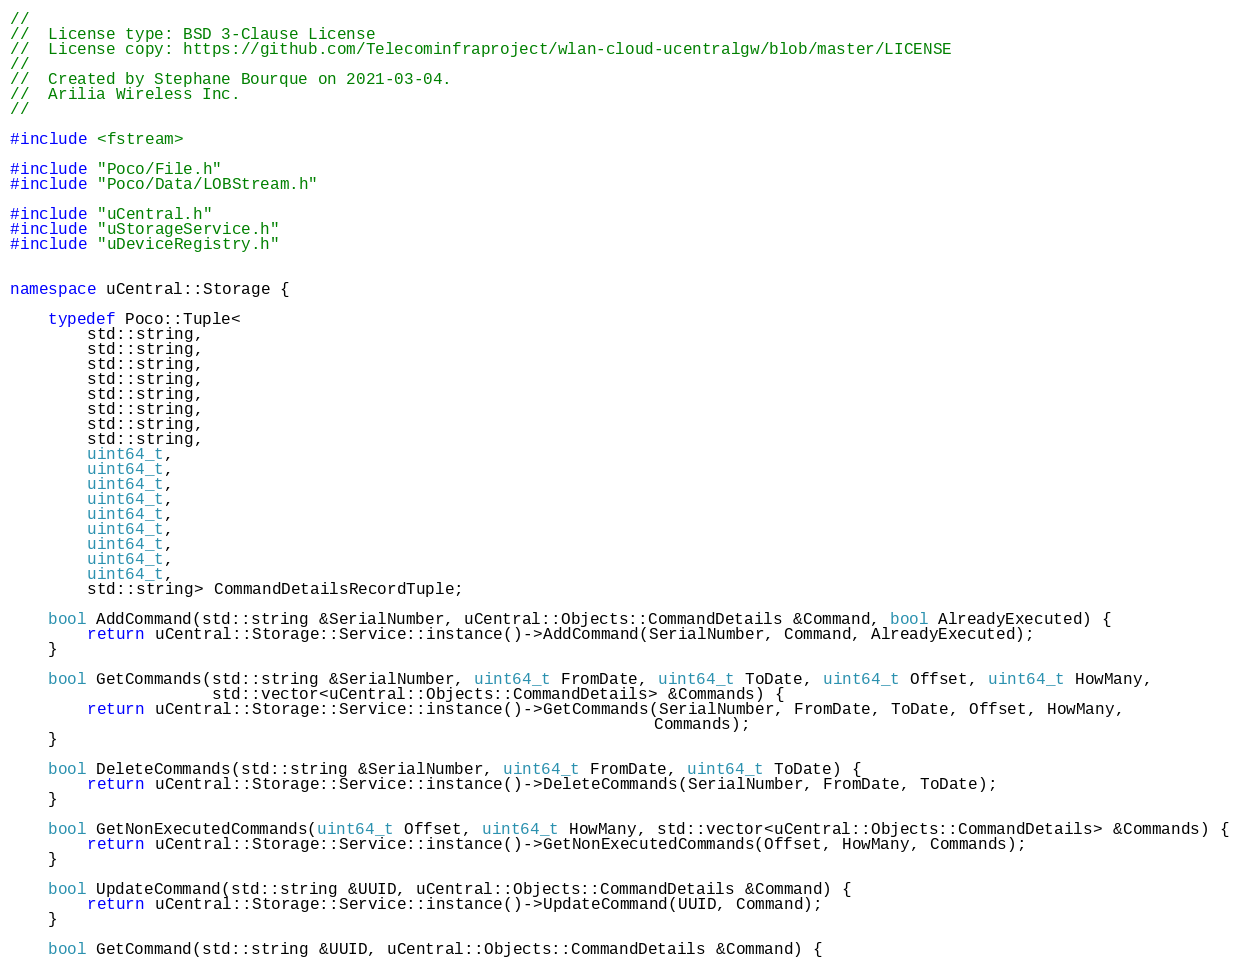Convert code to text. <code><loc_0><loc_0><loc_500><loc_500><_C++_>//
//	License type: BSD 3-Clause License
//	License copy: https://github.com/Telecominfraproject/wlan-cloud-ucentralgw/blob/master/LICENSE
//
//	Created by Stephane Bourque on 2021-03-04.
//	Arilia Wireless Inc.
//

#include <fstream>

#include "Poco/File.h"
#include "Poco/Data/LOBStream.h"

#include "uCentral.h"
#include "uStorageService.h"
#include "uDeviceRegistry.h"


namespace uCentral::Storage {

	typedef Poco::Tuple<
		std::string,
		std::string,
		std::string,
		std::string,
		std::string,
		std::string,
		std::string,
		std::string,
		uint64_t,
		uint64_t,
		uint64_t,
		uint64_t,
		uint64_t,
		uint64_t,
		uint64_t,
		uint64_t,
		uint64_t,
		std::string> CommandDetailsRecordTuple;

	bool AddCommand(std::string &SerialNumber, uCentral::Objects::CommandDetails &Command, bool AlreadyExecuted) {
		return uCentral::Storage::Service::instance()->AddCommand(SerialNumber, Command, AlreadyExecuted);
	}

	bool GetCommands(std::string &SerialNumber, uint64_t FromDate, uint64_t ToDate, uint64_t Offset, uint64_t HowMany,
					 std::vector<uCentral::Objects::CommandDetails> &Commands) {
		return uCentral::Storage::Service::instance()->GetCommands(SerialNumber, FromDate, ToDate, Offset, HowMany,
																   Commands);
	}

	bool DeleteCommands(std::string &SerialNumber, uint64_t FromDate, uint64_t ToDate) {
		return uCentral::Storage::Service::instance()->DeleteCommands(SerialNumber, FromDate, ToDate);
	}

	bool GetNonExecutedCommands(uint64_t Offset, uint64_t HowMany, std::vector<uCentral::Objects::CommandDetails> &Commands) {
		return uCentral::Storage::Service::instance()->GetNonExecutedCommands(Offset, HowMany, Commands);
	}

	bool UpdateCommand(std::string &UUID, uCentral::Objects::CommandDetails &Command) {
		return uCentral::Storage::Service::instance()->UpdateCommand(UUID, Command);
	}

	bool GetCommand(std::string &UUID, uCentral::Objects::CommandDetails &Command) {</code> 